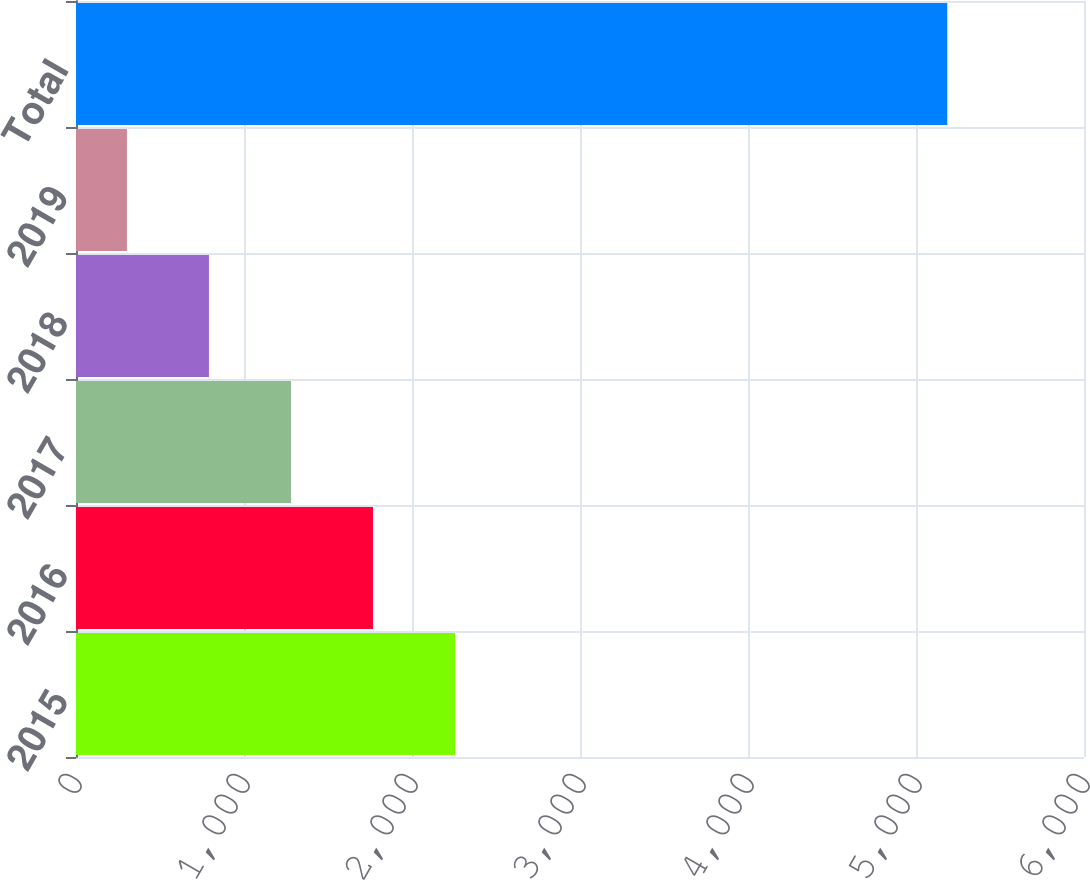Convert chart. <chart><loc_0><loc_0><loc_500><loc_500><bar_chart><fcel>2015<fcel>2016<fcel>2017<fcel>2018<fcel>2019<fcel>Total<nl><fcel>2256.2<fcel>1767.9<fcel>1279.6<fcel>791.3<fcel>303<fcel>5186<nl></chart> 